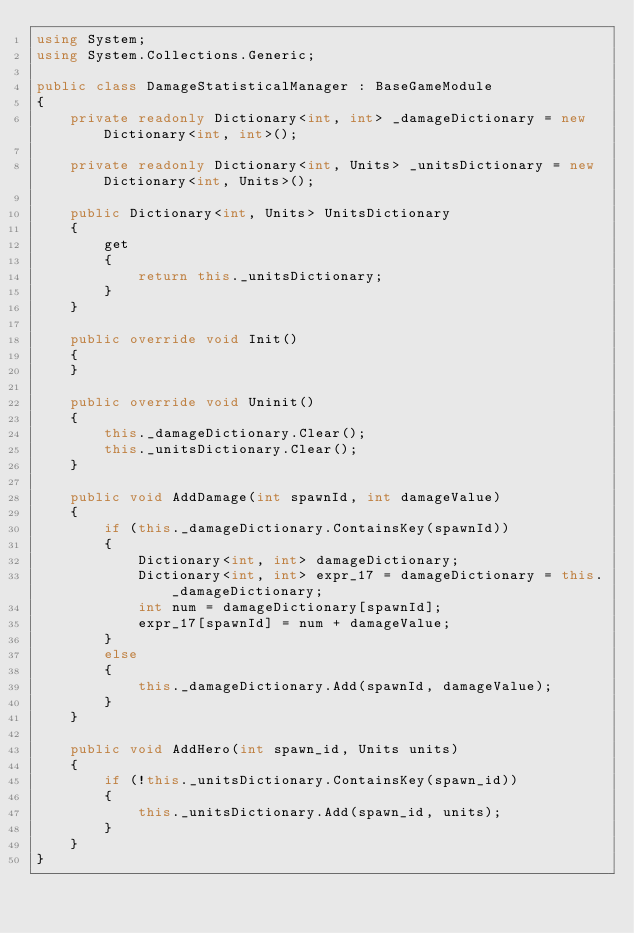<code> <loc_0><loc_0><loc_500><loc_500><_C#_>using System;
using System.Collections.Generic;

public class DamageStatisticalManager : BaseGameModule
{
	private readonly Dictionary<int, int> _damageDictionary = new Dictionary<int, int>();

	private readonly Dictionary<int, Units> _unitsDictionary = new Dictionary<int, Units>();

	public Dictionary<int, Units> UnitsDictionary
	{
		get
		{
			return this._unitsDictionary;
		}
	}

	public override void Init()
	{
	}

	public override void Uninit()
	{
		this._damageDictionary.Clear();
		this._unitsDictionary.Clear();
	}

	public void AddDamage(int spawnId, int damageValue)
	{
		if (this._damageDictionary.ContainsKey(spawnId))
		{
			Dictionary<int, int> damageDictionary;
			Dictionary<int, int> expr_17 = damageDictionary = this._damageDictionary;
			int num = damageDictionary[spawnId];
			expr_17[spawnId] = num + damageValue;
		}
		else
		{
			this._damageDictionary.Add(spawnId, damageValue);
		}
	}

	public void AddHero(int spawn_id, Units units)
	{
		if (!this._unitsDictionary.ContainsKey(spawn_id))
		{
			this._unitsDictionary.Add(spawn_id, units);
		}
	}
}
</code> 